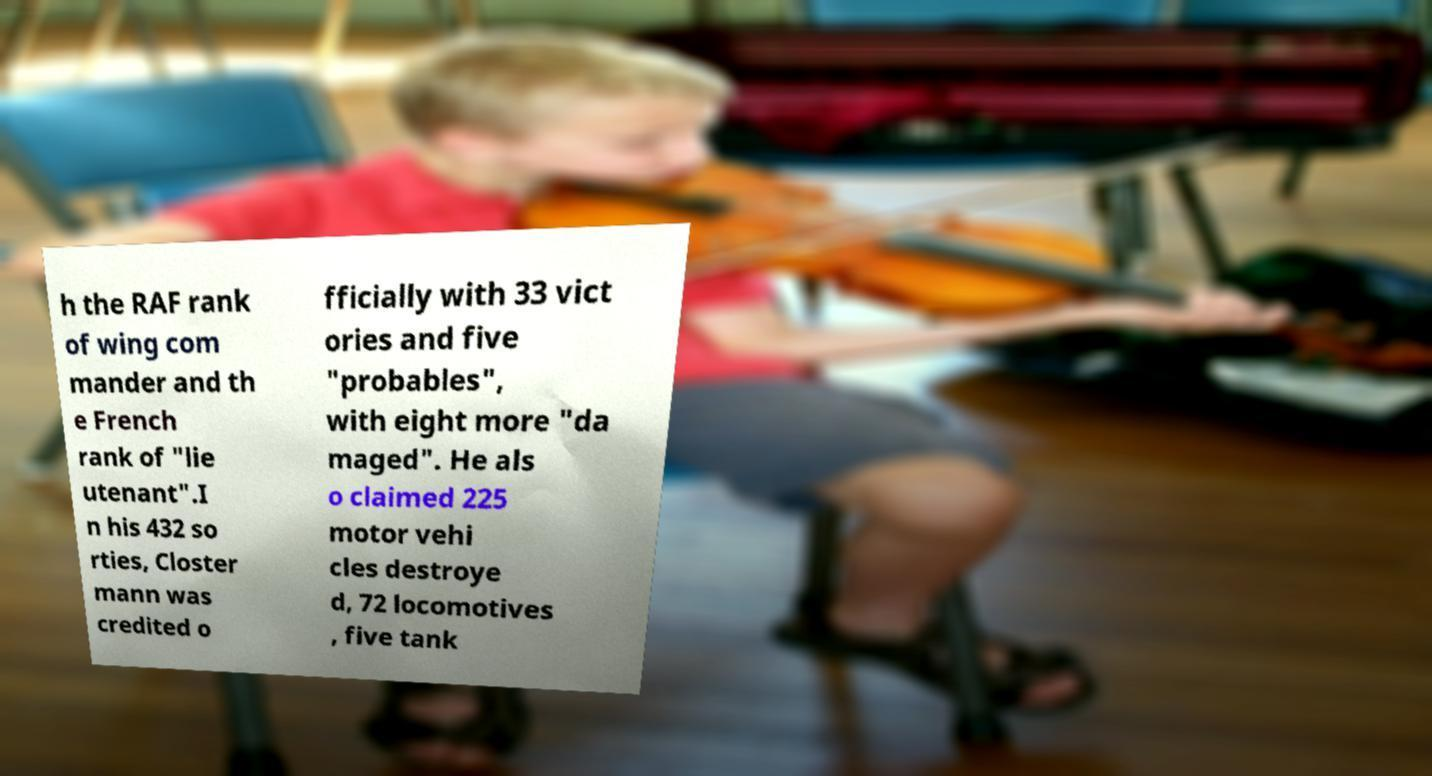What messages or text are displayed in this image? I need them in a readable, typed format. h the RAF rank of wing com mander and th e French rank of "lie utenant".I n his 432 so rties, Closter mann was credited o fficially with 33 vict ories and five "probables", with eight more "da maged". He als o claimed 225 motor vehi cles destroye d, 72 locomotives , five tank 